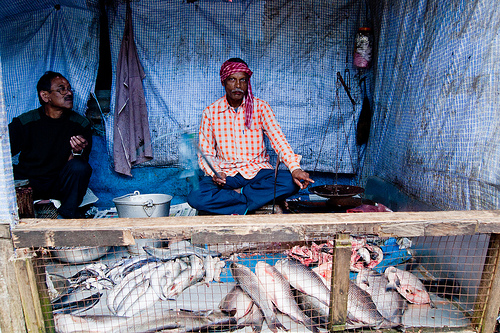<image>
Is the gate in front of the fish? Yes. The gate is positioned in front of the fish, appearing closer to the camera viewpoint. 